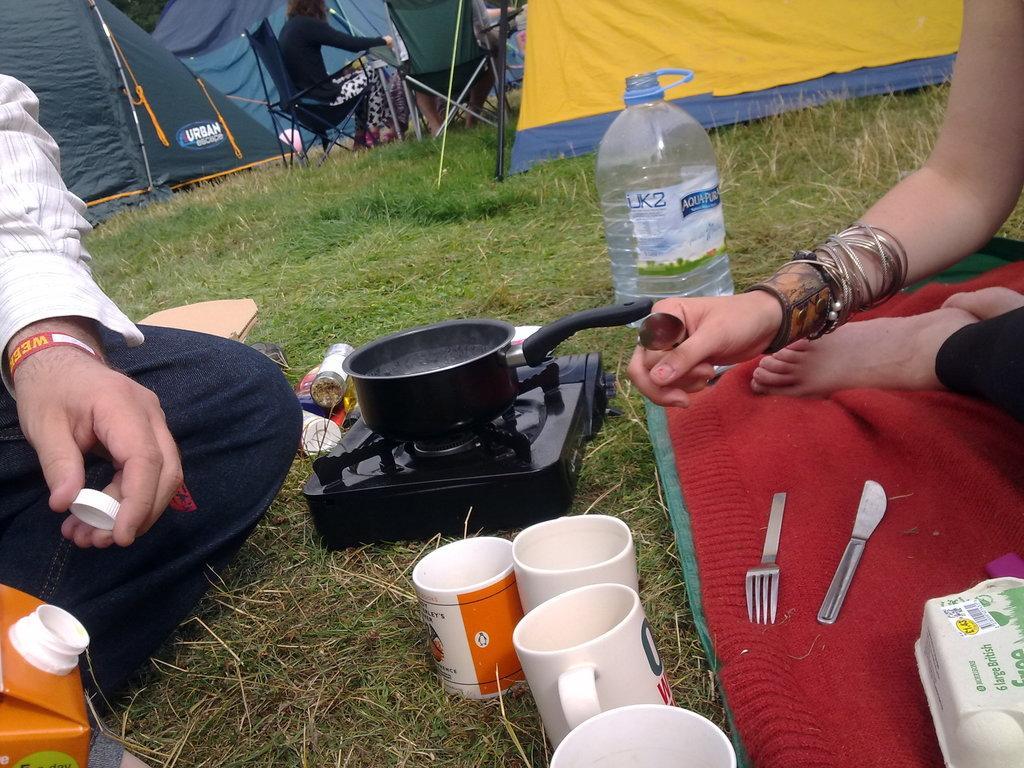Please provide a concise description of this image. This picture is clicked at outside. On the right there is a woman she is holding a spoon. On the left there is a man he wear shirt and trouser. In the middle there is a bottle, stove, cups, tent, chair and grass. 